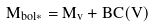<formula> <loc_0><loc_0><loc_500><loc_500>M _ { b o l \ast } = M _ { v } + B C ( V )</formula> 